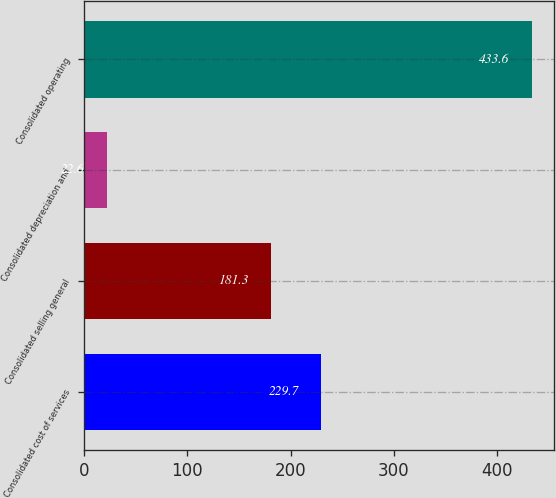Convert chart. <chart><loc_0><loc_0><loc_500><loc_500><bar_chart><fcel>Consolidated cost of services<fcel>Consolidated selling general<fcel>Consolidated depreciation and<fcel>Consolidated operating<nl><fcel>229.7<fcel>181.3<fcel>22.6<fcel>433.6<nl></chart> 